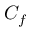<formula> <loc_0><loc_0><loc_500><loc_500>C _ { f }</formula> 